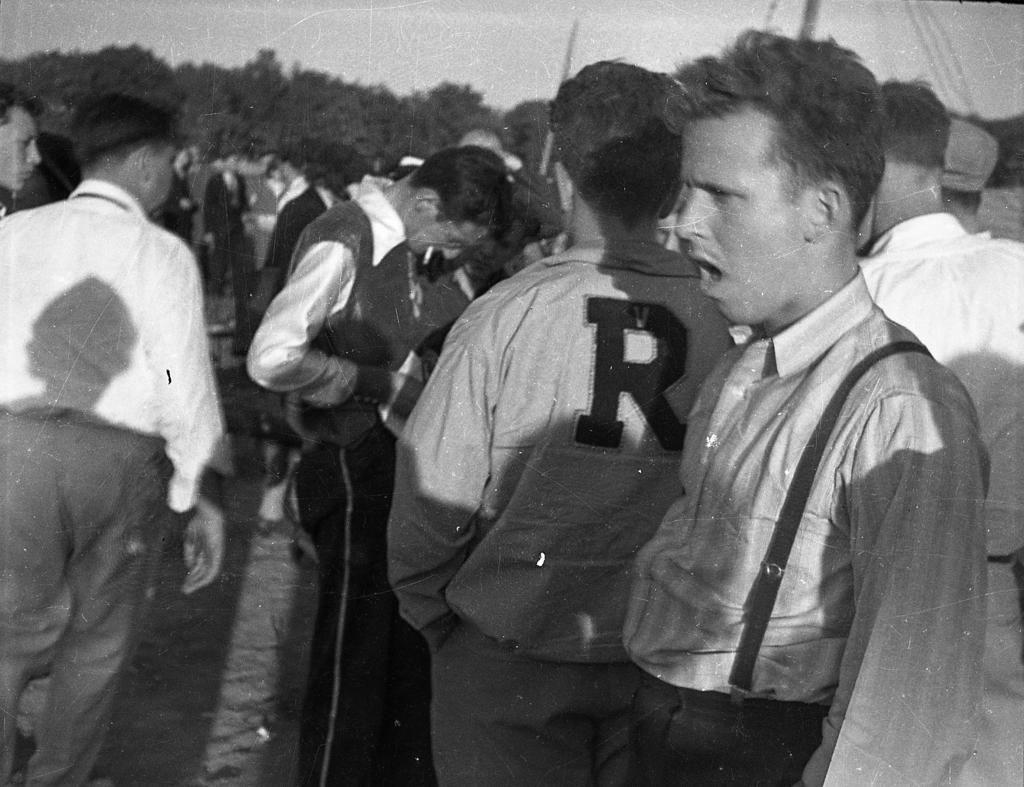What is the color scheme of the image? The image is black and white. How many people can be seen in the image? There are many people standing in the image. What can be seen in the background of the image? There are trees in the background of the image. What objects are visible among the people in the image? There are sticks visible in the image. What type of creature is sitting on the committee in the image? There is no committee or creature present in the image. Can you tell me how many railway tracks are visible in the image? There are no railway tracks visible in the image. 